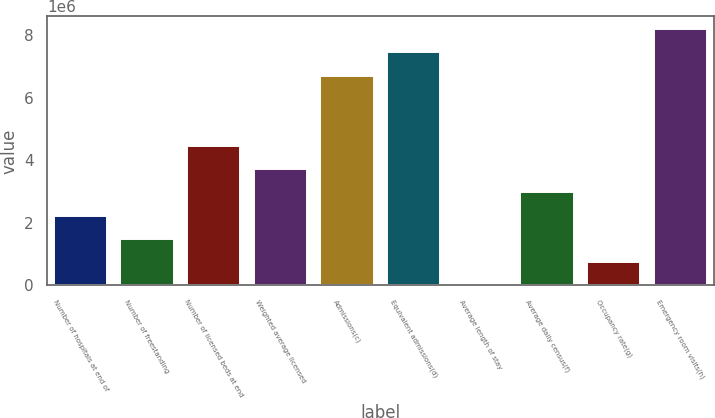<chart> <loc_0><loc_0><loc_500><loc_500><bar_chart><fcel>Number of hospitals at end of<fcel>Number of freestanding<fcel>Number of licensed beds at end<fcel>Weighted average licensed<fcel>Admissions(c)<fcel>Equivalent admissions(d)<fcel>Average length of stay<fcel>Average daily census(f)<fcel>Occupancy rate(g)<fcel>Emergency room visits(h)<nl><fcel>2.23521e+06<fcel>1.49014e+06<fcel>4.47042e+06<fcel>3.72535e+06<fcel>6.70563e+06<fcel>7.4507e+06<fcel>4.8<fcel>2.98028e+06<fcel>745074<fcel>8.19577e+06<nl></chart> 